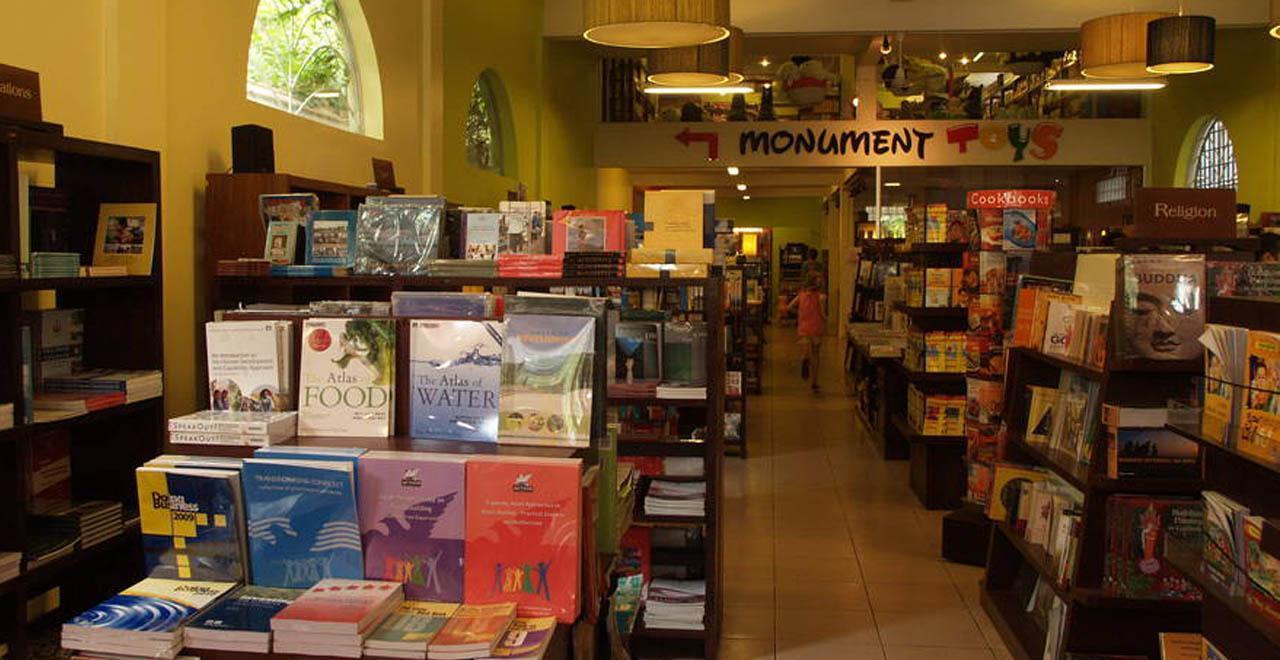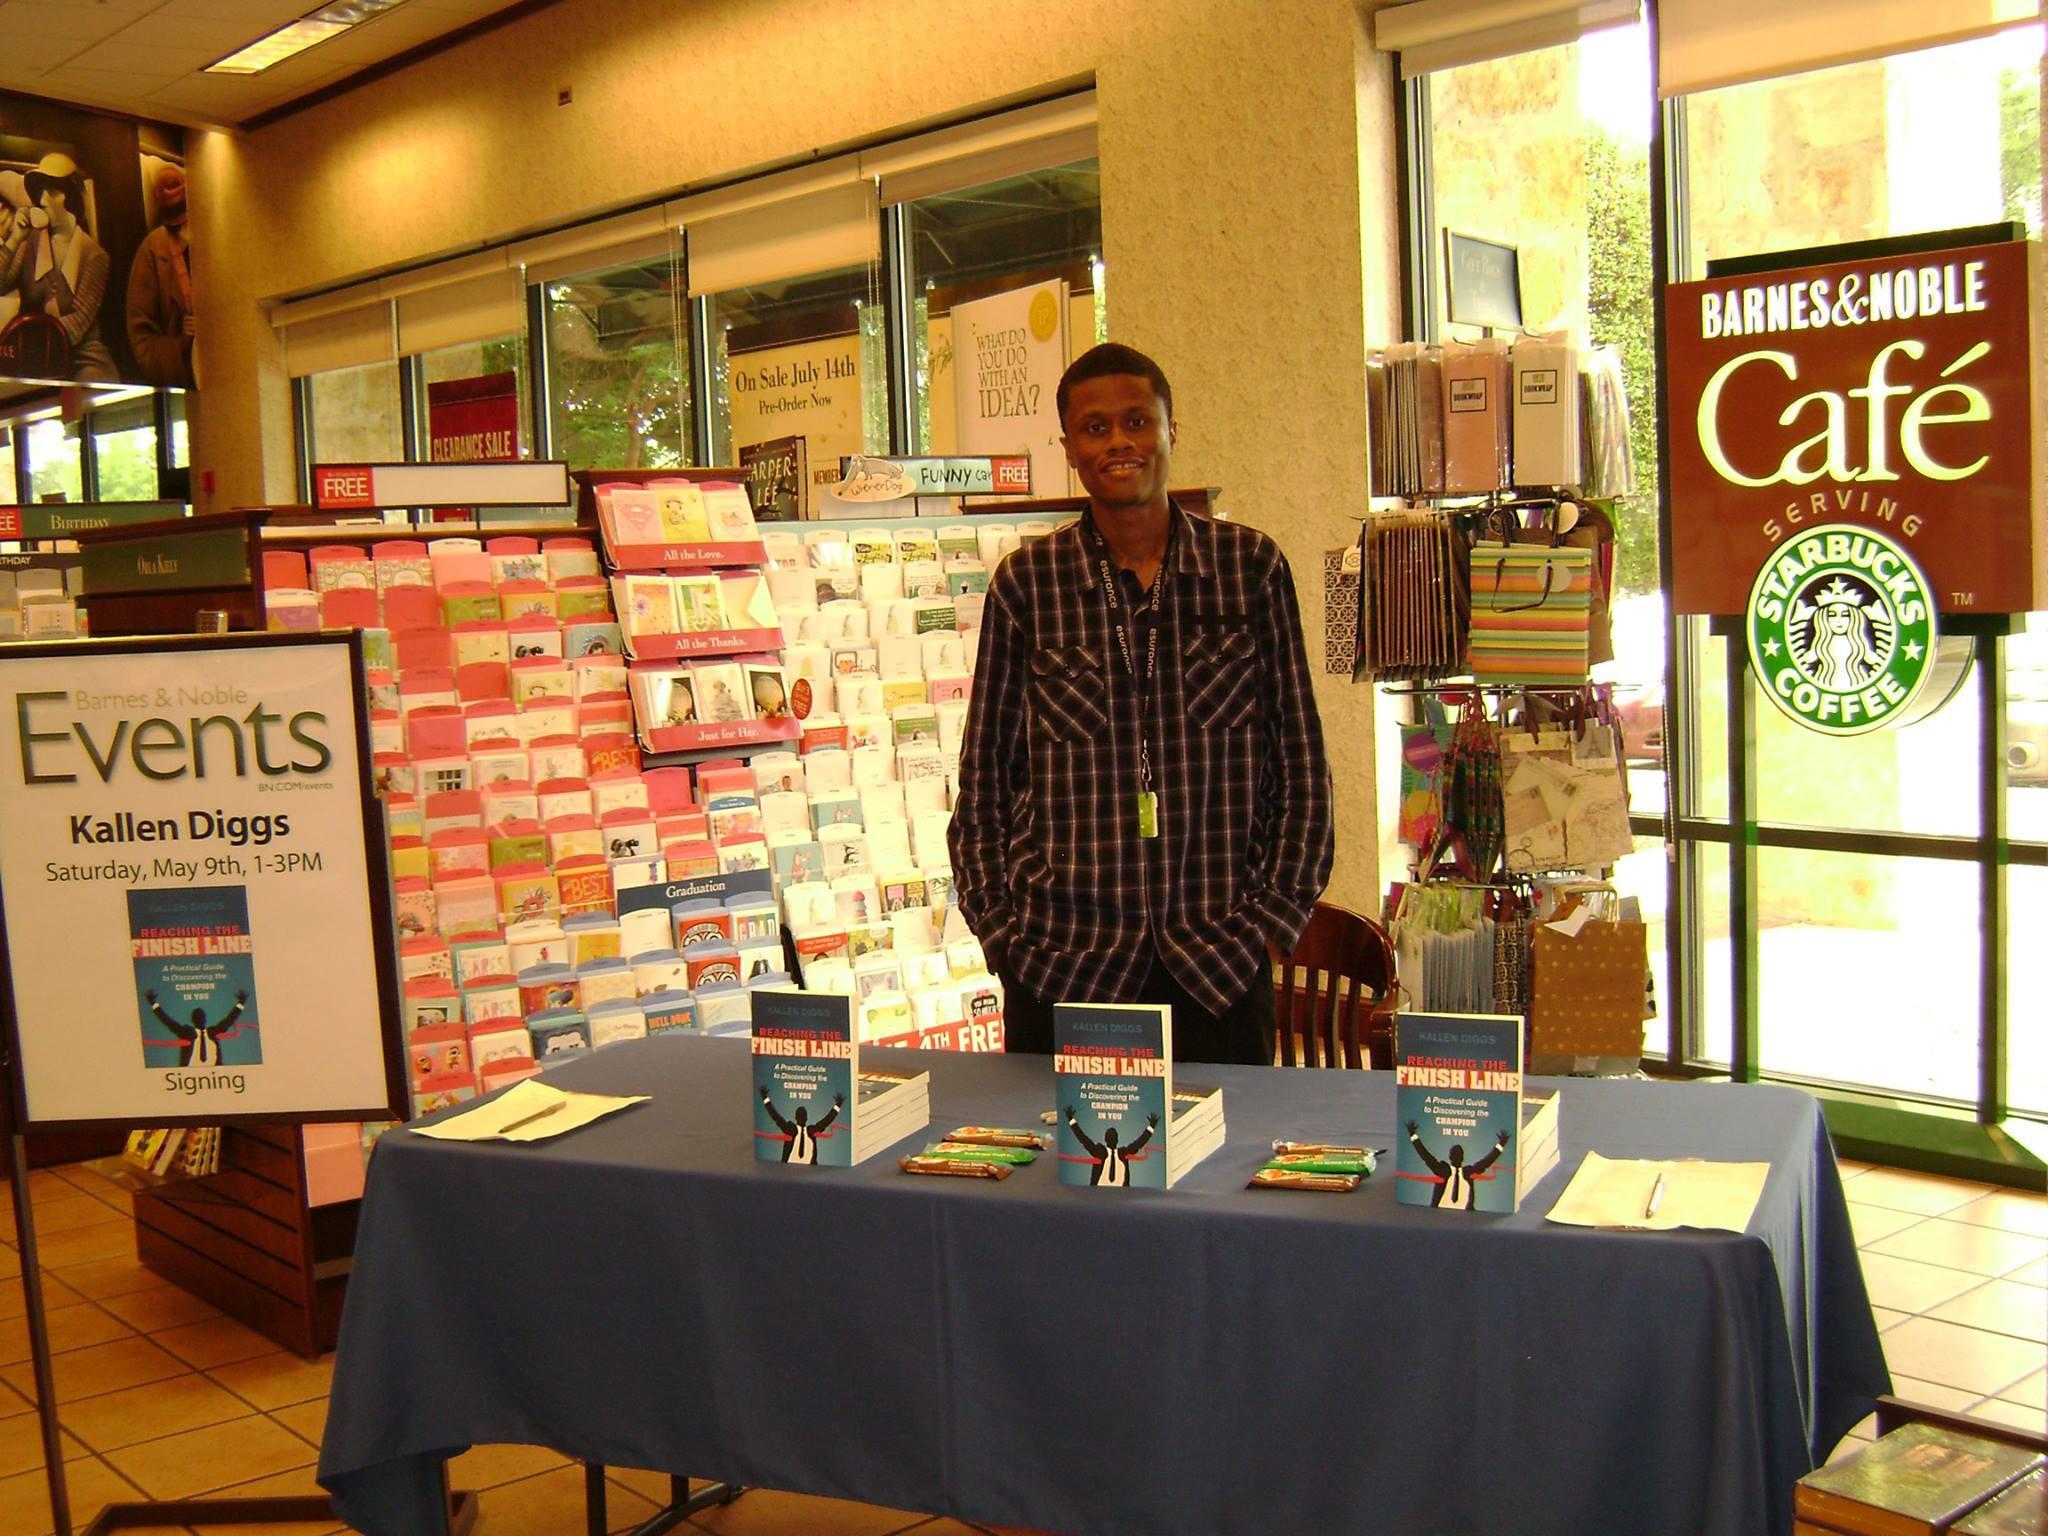The first image is the image on the left, the second image is the image on the right. Considering the images on both sides, is "A man with a gray beard and glasses stands behind a counter stacked with books in one image, and the other image shows a display with a book's front cover." valid? Answer yes or no. No. The first image is the image on the left, the second image is the image on the right. Considering the images on both sides, is "In one image there is a man with a beard in a bookstore." valid? Answer yes or no. No. 